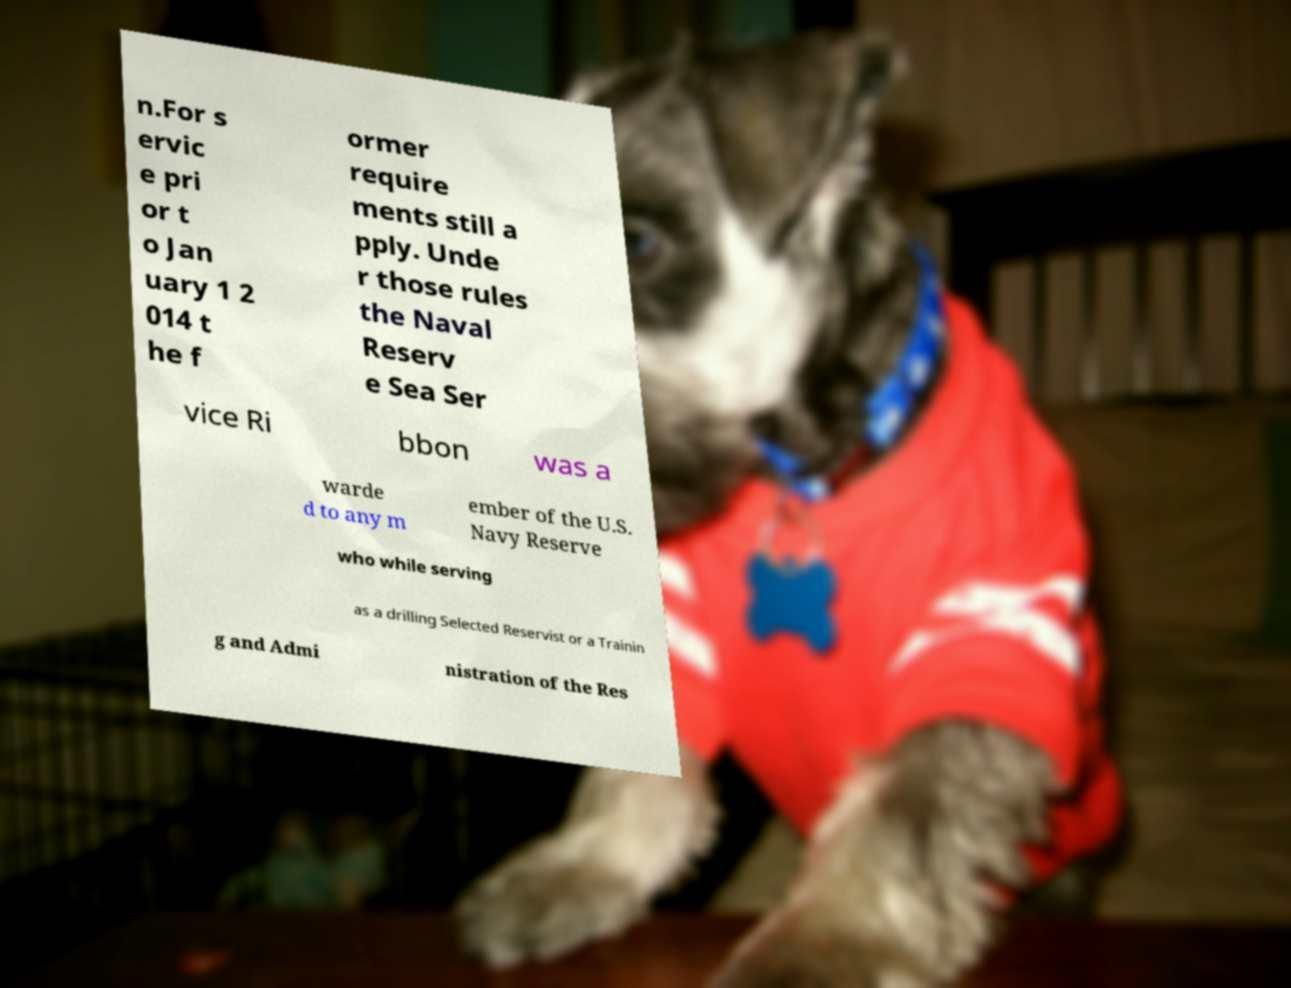Can you accurately transcribe the text from the provided image for me? n.For s ervic e pri or t o Jan uary 1 2 014 t he f ormer require ments still a pply. Unde r those rules the Naval Reserv e Sea Ser vice Ri bbon was a warde d to any m ember of the U.S. Navy Reserve who while serving as a drilling Selected Reservist or a Trainin g and Admi nistration of the Res 